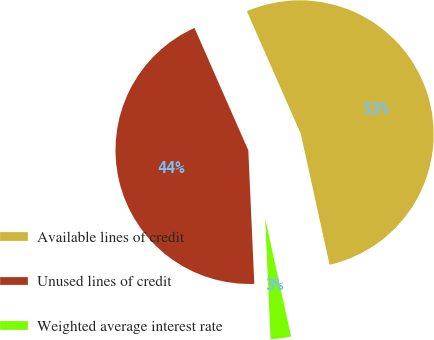Convert chart to OTSL. <chart><loc_0><loc_0><loc_500><loc_500><pie_chart><fcel>Available lines of credit<fcel>Unused lines of credit<fcel>Weighted average interest rate<nl><fcel>53.15%<fcel>44.12%<fcel>2.73%<nl></chart> 